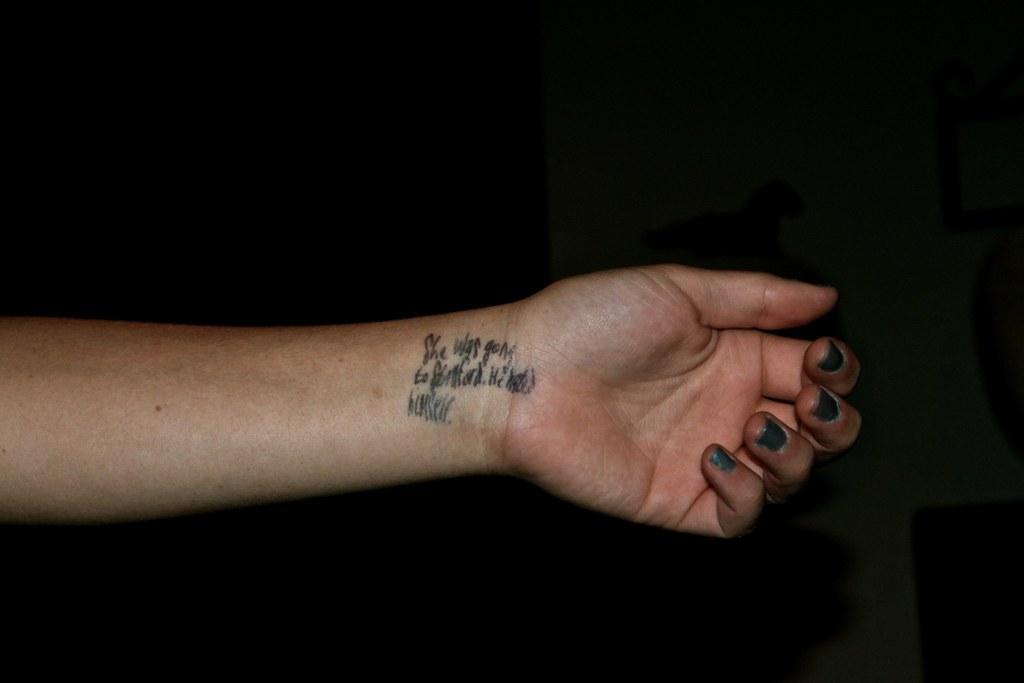Can you describe this image briefly? In this image we can see a person's hand, on the hand we can see some text and the background is dark. 